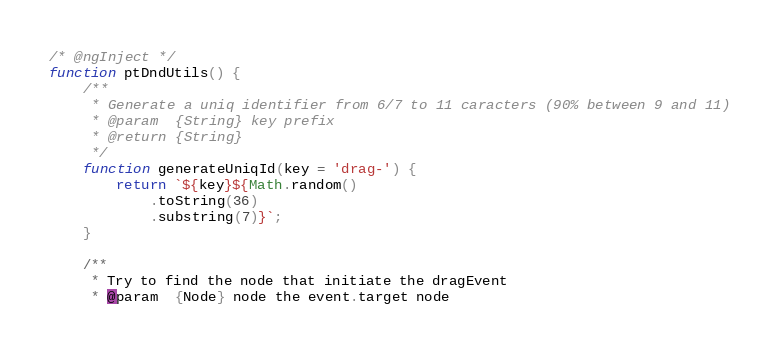Convert code to text. <code><loc_0><loc_0><loc_500><loc_500><_JavaScript_>/* @ngInject */
function ptDndUtils() {
    /**
     * Generate a uniq identifier from 6/7 to 11 caracters (90% between 9 and 11)
     * @param  {String} key prefix
     * @return {String}
     */
    function generateUniqId(key = 'drag-') {
        return `${key}${Math.random()
            .toString(36)
            .substring(7)}`;
    }

    /**
     * Try to find the node that initiate the dragEvent
     * @param  {Node} node the event.target node</code> 